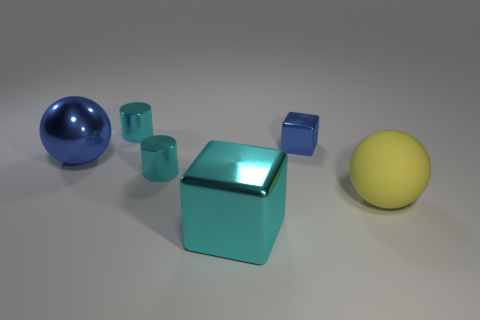How many small yellow rubber cylinders are there?
Your answer should be compact. 0. Is the number of large yellow rubber balls in front of the big cyan block less than the number of green rubber cubes?
Keep it short and to the point. No. Does the blue thing that is to the left of the large cyan metallic cube have the same material as the yellow object?
Make the answer very short. No. There is a small cyan metal thing that is behind the blue object behind the large thing that is on the left side of the cyan cube; what is its shape?
Your answer should be very brief. Cylinder. Are there any cyan shiny things that have the same size as the yellow ball?
Offer a terse response. Yes. The blue cube is what size?
Keep it short and to the point. Small. How many red shiny cylinders are the same size as the matte sphere?
Provide a succinct answer. 0. Are there fewer cyan metallic things that are behind the tiny blue metallic thing than objects that are behind the big cyan object?
Provide a short and direct response. Yes. There is a blue metallic thing that is right of the tiny cyan cylinder that is behind the large sphere that is behind the rubber object; what size is it?
Offer a terse response. Small. There is a cyan thing that is both in front of the tiny blue metallic cube and behind the cyan metal block; what is its size?
Provide a short and direct response. Small. 